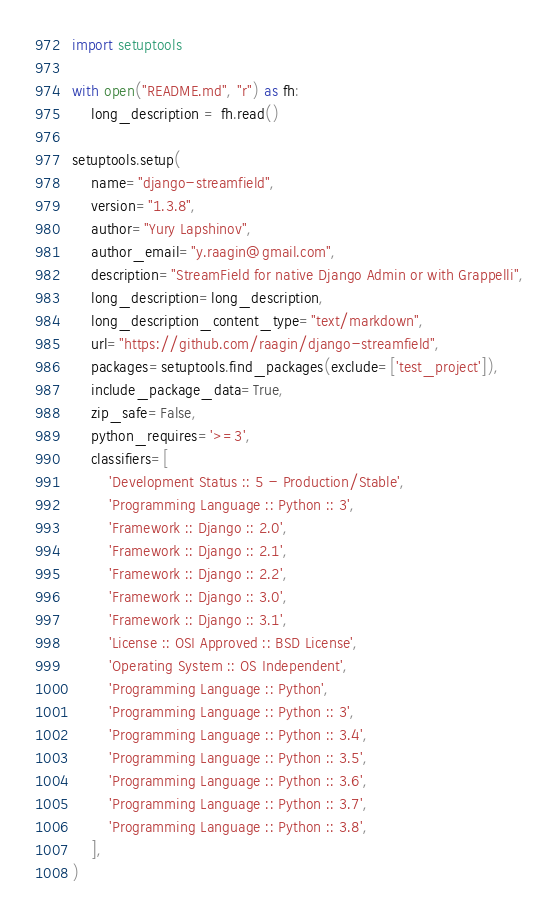<code> <loc_0><loc_0><loc_500><loc_500><_Python_>import setuptools

with open("README.md", "r") as fh:
    long_description = fh.read()

setuptools.setup(
    name="django-streamfield",
    version="1.3.8",
    author="Yury Lapshinov",
    author_email="y.raagin@gmail.com",
    description="StreamField for native Django Admin or with Grappelli",
    long_description=long_description,
    long_description_content_type="text/markdown",
    url="https://github.com/raagin/django-streamfield",
    packages=setuptools.find_packages(exclude=['test_project']),
    include_package_data=True,
    zip_safe=False,
    python_requires='>=3',
    classifiers=[
        'Development Status :: 5 - Production/Stable',
        'Programming Language :: Python :: 3',
        'Framework :: Django :: 2.0',
        'Framework :: Django :: 2.1',
        'Framework :: Django :: 2.2',
        'Framework :: Django :: 3.0',
        'Framework :: Django :: 3.1',
        'License :: OSI Approved :: BSD License',
        'Operating System :: OS Independent',
        'Programming Language :: Python',
        'Programming Language :: Python :: 3',
        'Programming Language :: Python :: 3.4',
        'Programming Language :: Python :: 3.5',
        'Programming Language :: Python :: 3.6',
        'Programming Language :: Python :: 3.7',
        'Programming Language :: Python :: 3.8',
    ],
)</code> 